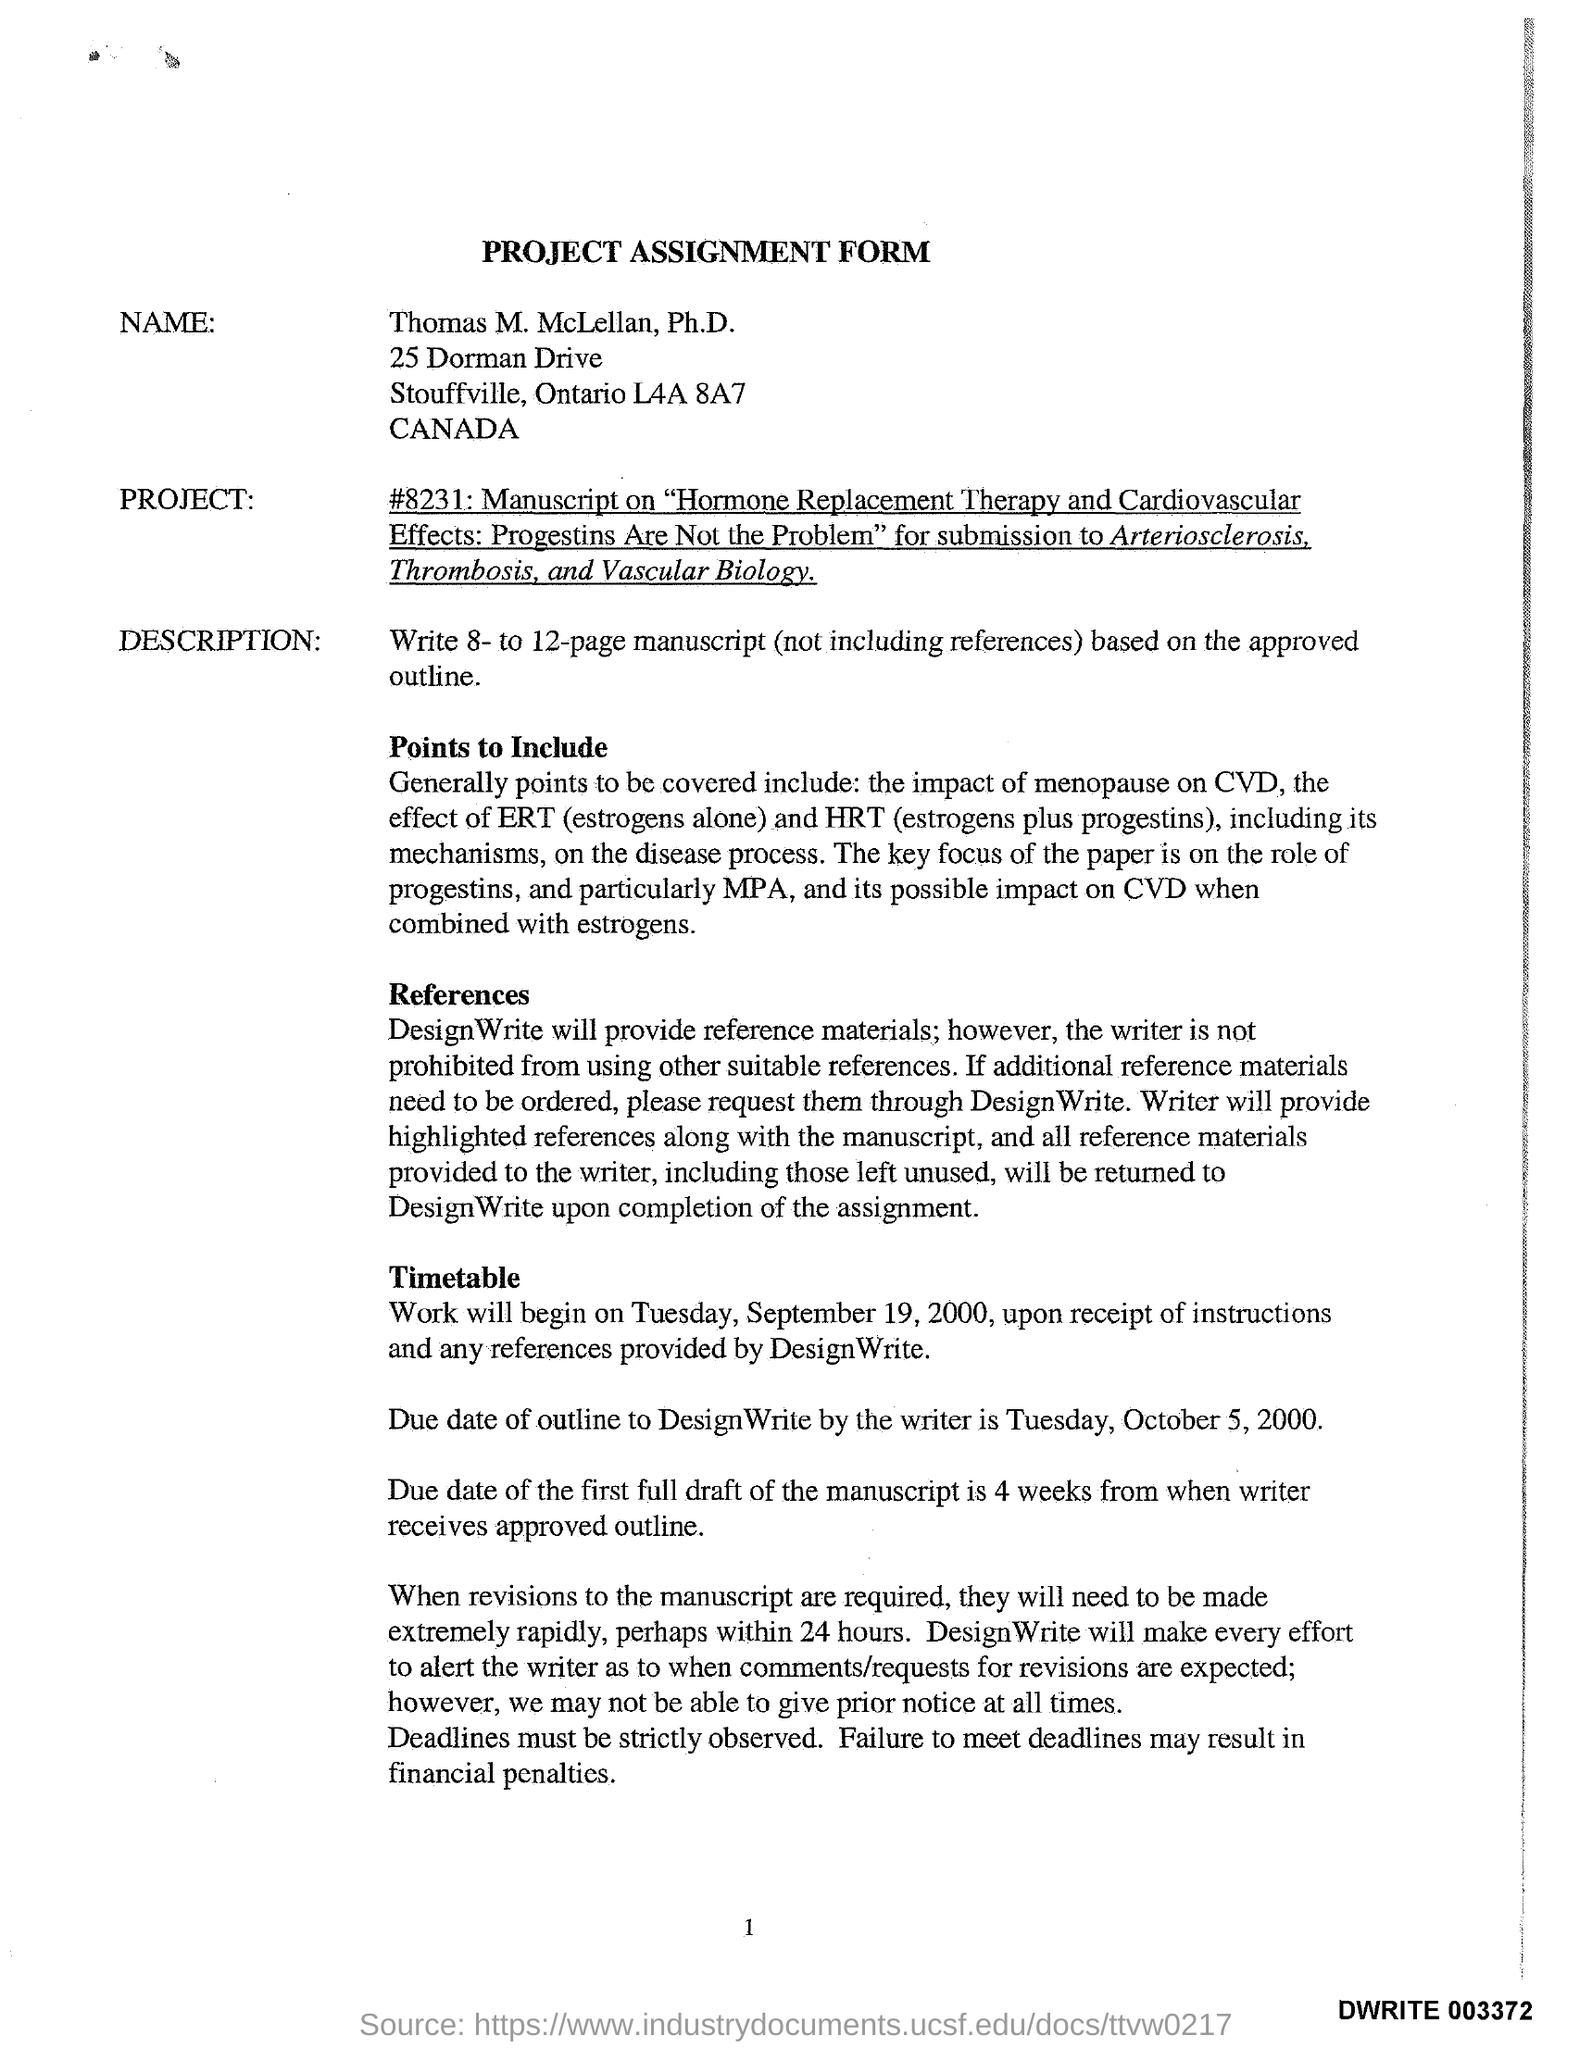What is the Title of the Form?
Your answer should be very brief. Project Assignment Form. What is the Name on the Form?
Make the answer very short. Thomas M. McLellan. When will the work begin?
Offer a terse response. Tuesday, September 19, 2000, upon receipt of instructions and any references provided by DesignWrite. What is the due date of Outline to DesignWrite by the writer?
Provide a succinct answer. Tuesday, October 5, 2000. 